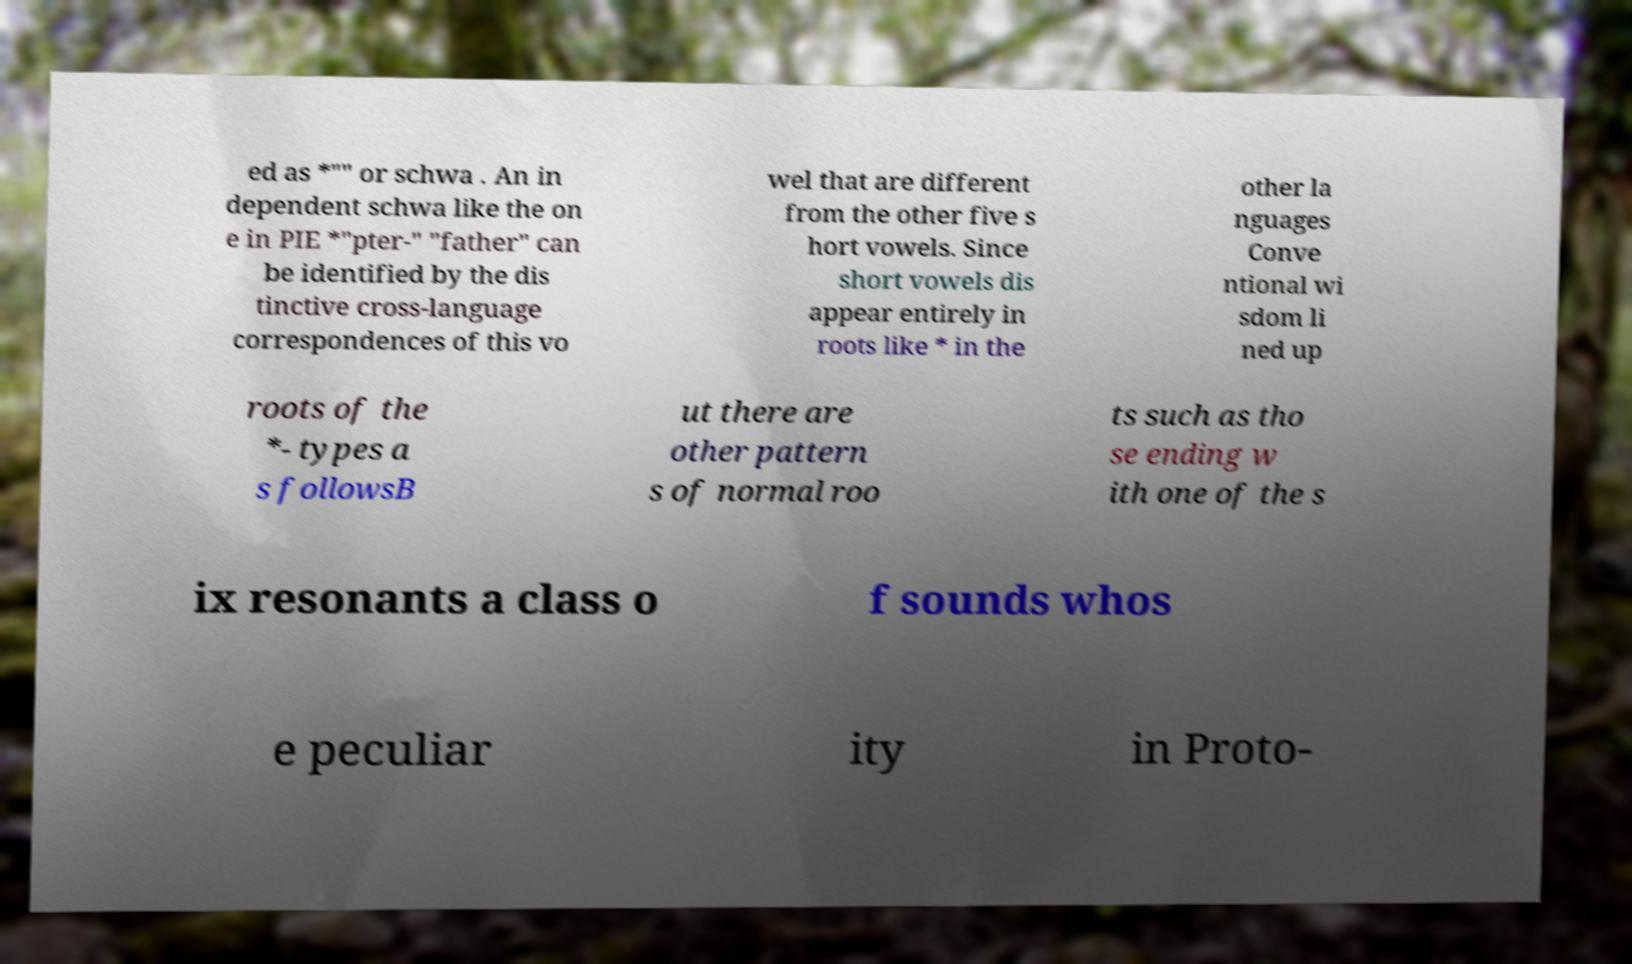For documentation purposes, I need the text within this image transcribed. Could you provide that? ed as *"" or schwa . An in dependent schwa like the on e in PIE *"pter-" "father" can be identified by the dis tinctive cross-language correspondences of this vo wel that are different from the other five s hort vowels. Since short vowels dis appear entirely in roots like * in the other la nguages Conve ntional wi sdom li ned up roots of the *- types a s followsB ut there are other pattern s of normal roo ts such as tho se ending w ith one of the s ix resonants a class o f sounds whos e peculiar ity in Proto- 